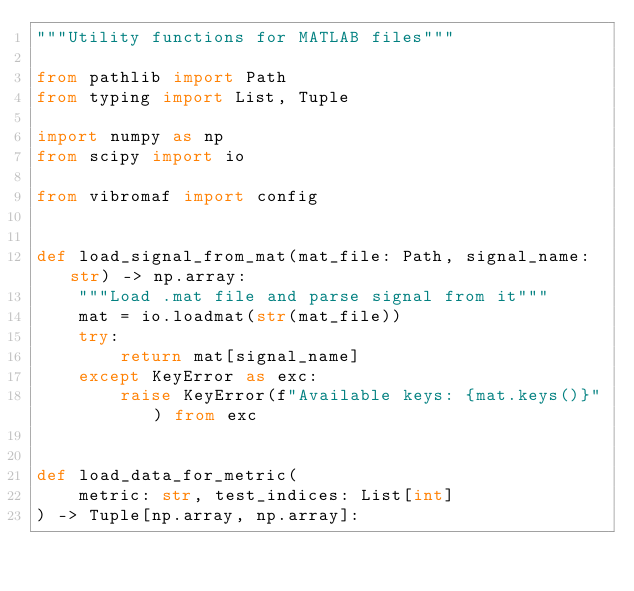<code> <loc_0><loc_0><loc_500><loc_500><_Python_>"""Utility functions for MATLAB files"""

from pathlib import Path
from typing import List, Tuple

import numpy as np
from scipy import io

from vibromaf import config


def load_signal_from_mat(mat_file: Path, signal_name: str) -> np.array:
    """Load .mat file and parse signal from it"""
    mat = io.loadmat(str(mat_file))
    try:
        return mat[signal_name]
    except KeyError as exc:
        raise KeyError(f"Available keys: {mat.keys()}") from exc


def load_data_for_metric(
    metric: str, test_indices: List[int]
) -> Tuple[np.array, np.array]:</code> 